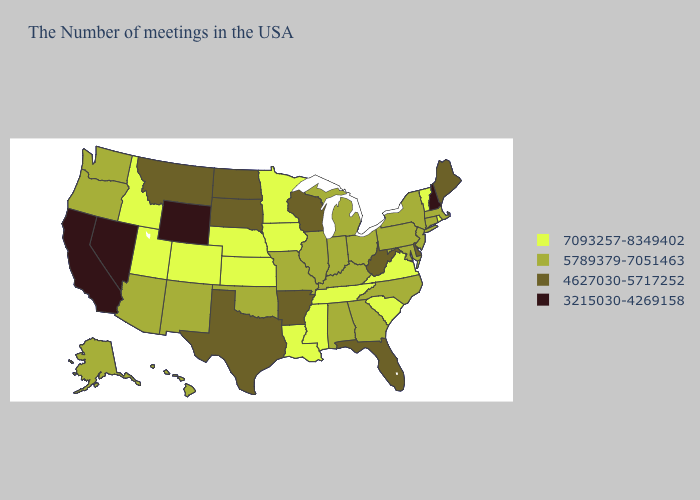Among the states that border Wyoming , which have the highest value?
Quick response, please. Nebraska, Colorado, Utah, Idaho. What is the highest value in the Northeast ?
Answer briefly. 7093257-8349402. What is the value of Massachusetts?
Be succinct. 5789379-7051463. Does North Dakota have the same value as Oklahoma?
Give a very brief answer. No. Among the states that border Louisiana , does Arkansas have the lowest value?
Answer briefly. Yes. Among the states that border Wisconsin , does Iowa have the highest value?
Short answer required. Yes. Does Colorado have the highest value in the USA?
Quick response, please. Yes. What is the lowest value in the Northeast?
Keep it brief. 3215030-4269158. Name the states that have a value in the range 4627030-5717252?
Give a very brief answer. Maine, Delaware, West Virginia, Florida, Wisconsin, Arkansas, Texas, South Dakota, North Dakota, Montana. What is the value of South Carolina?
Give a very brief answer. 7093257-8349402. Among the states that border Wisconsin , does Michigan have the lowest value?
Keep it brief. Yes. Does Virginia have the highest value in the South?
Concise answer only. Yes. Name the states that have a value in the range 3215030-4269158?
Answer briefly. New Hampshire, Wyoming, Nevada, California. What is the value of Hawaii?
Concise answer only. 5789379-7051463. Among the states that border New Jersey , which have the highest value?
Answer briefly. New York, Pennsylvania. 